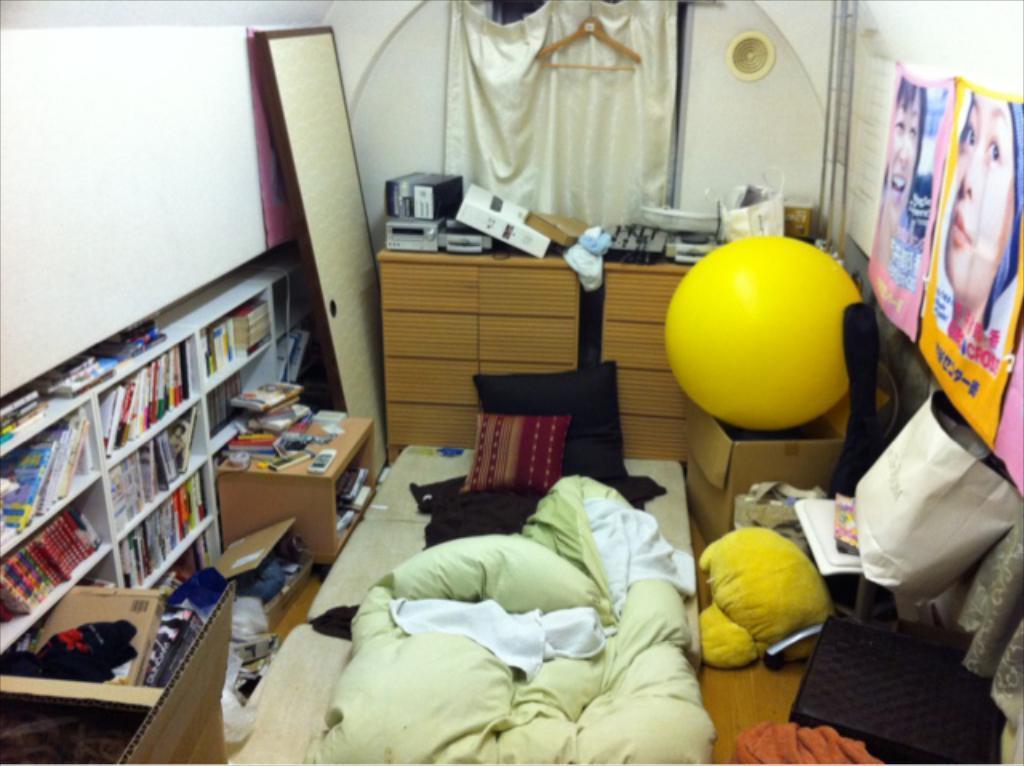In one or two sentences, can you explain what this image depicts? This picture is of inside the room. In the foreground we can see a blanket, pillows, box, some clothes and a shelf of books. On the right there are some posters hanging on the wall. In the background we can see a curtain, a hanger, a cabinet and some machines are placed on that and a wall. 